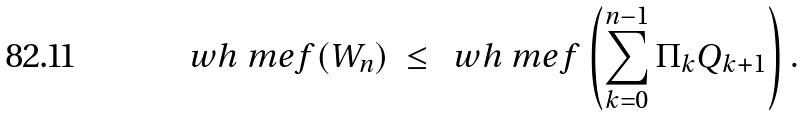<formula> <loc_0><loc_0><loc_500><loc_500>\ w h \ m e f ( W _ { n } ) \ \leq \ \ w h \ m e f \left ( \sum _ { k = 0 } ^ { n - 1 } \Pi _ { k } Q _ { k + 1 } \right ) .</formula> 